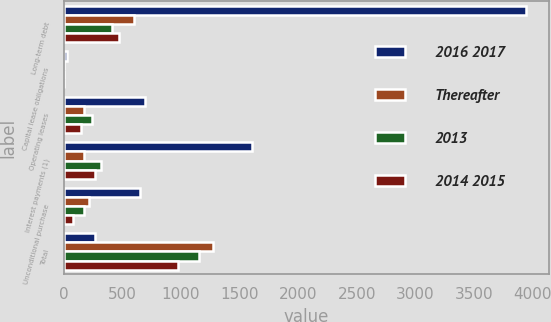Convert chart to OTSL. <chart><loc_0><loc_0><loc_500><loc_500><stacked_bar_chart><ecel><fcel>Long-term debt<fcel>Capital lease obligations<fcel>Operating leases<fcel>Interest payments (1)<fcel>Unconditional purchase<fcel>Total<nl><fcel>2016 2017<fcel>3939<fcel>32<fcel>695<fcel>1604<fcel>648<fcel>269<nl><fcel>Thereafter<fcel>600<fcel>3<fcel>171<fcel>173<fcel>212<fcel>1275<nl><fcel>2013<fcel>409<fcel>5<fcel>242<fcel>322<fcel>174<fcel>1152<nl><fcel>2014 2015<fcel>472<fcel>5<fcel>147<fcel>269<fcel>82<fcel>975<nl></chart> 